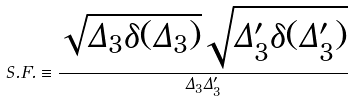Convert formula to latex. <formula><loc_0><loc_0><loc_500><loc_500>S . F . \equiv \frac { \sqrt { \Delta _ { 3 } \delta ( \Delta _ { 3 } ) } \sqrt { \Delta _ { 3 } ^ { \prime } \delta ( \Delta _ { 3 } ^ { \prime } ) } } { \Delta _ { 3 } \Delta _ { 3 } ^ { \prime } }</formula> 